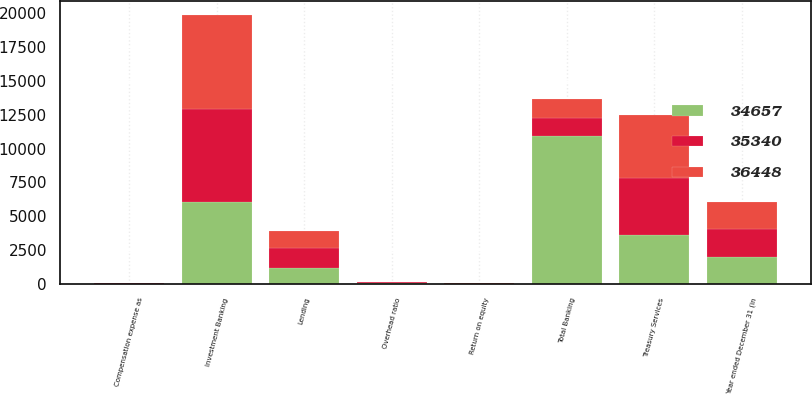Convert chart to OTSL. <chart><loc_0><loc_0><loc_500><loc_500><stacked_bar_chart><ecel><fcel>Year ended December 31 (in<fcel>Return on equity<fcel>Overhead ratio<fcel>Compensation expense as<fcel>Investment Banking<fcel>Treasury Services<fcel>Lending<fcel>Total Banking<nl><fcel>36448<fcel>2018<fcel>16<fcel>57<fcel>28<fcel>6987<fcel>4697<fcel>1298<fcel>1363.5<nl><fcel>35340<fcel>2017<fcel>14<fcel>56<fcel>28<fcel>6852<fcel>4172<fcel>1429<fcel>1363.5<nl><fcel>34657<fcel>2016<fcel>16<fcel>54<fcel>27<fcel>6074<fcel>3643<fcel>1208<fcel>10925<nl></chart> 